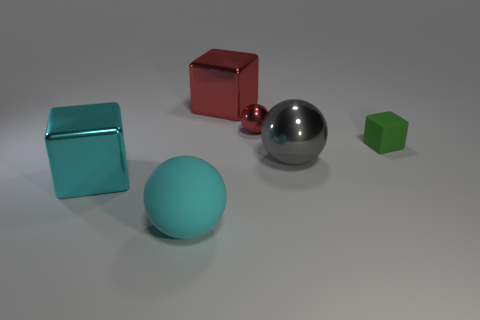There is a matte object in front of the large thing that is to the right of the big red object; what is its color?
Your response must be concise. Cyan. How many other objects are there of the same color as the small rubber object?
Ensure brevity in your answer.  0. How many objects are brown rubber balls or cyan objects that are on the right side of the big cyan cube?
Provide a short and direct response. 1. The big cube left of the big red cube is what color?
Give a very brief answer. Cyan. There is a tiny red thing; what shape is it?
Keep it short and to the point. Sphere. What material is the small green object behind the big block that is in front of the green rubber block?
Your answer should be compact. Rubber. What number of other things are there of the same material as the big cyan ball
Offer a terse response. 1. What material is the block that is the same size as the red ball?
Make the answer very short. Rubber. Are there more small metal spheres that are on the left side of the big cyan shiny object than large spheres behind the small red ball?
Keep it short and to the point. No. Are there any other big things of the same shape as the gray thing?
Ensure brevity in your answer.  Yes. 